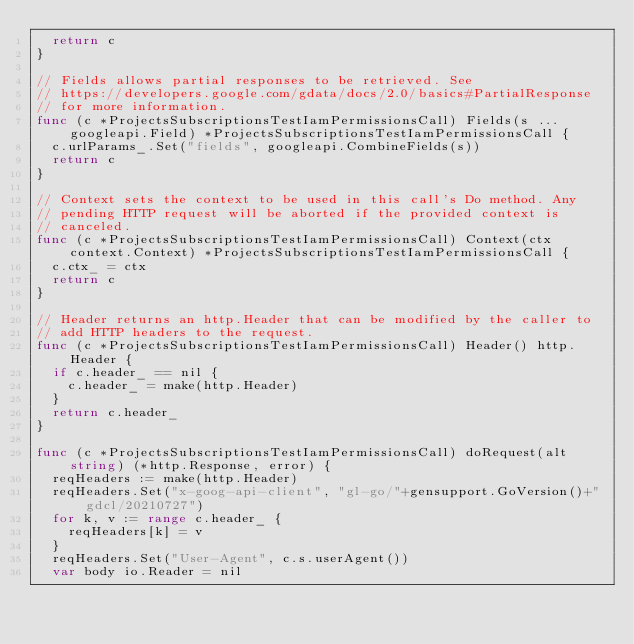<code> <loc_0><loc_0><loc_500><loc_500><_Go_>	return c
}

// Fields allows partial responses to be retrieved. See
// https://developers.google.com/gdata/docs/2.0/basics#PartialResponse
// for more information.
func (c *ProjectsSubscriptionsTestIamPermissionsCall) Fields(s ...googleapi.Field) *ProjectsSubscriptionsTestIamPermissionsCall {
	c.urlParams_.Set("fields", googleapi.CombineFields(s))
	return c
}

// Context sets the context to be used in this call's Do method. Any
// pending HTTP request will be aborted if the provided context is
// canceled.
func (c *ProjectsSubscriptionsTestIamPermissionsCall) Context(ctx context.Context) *ProjectsSubscriptionsTestIamPermissionsCall {
	c.ctx_ = ctx
	return c
}

// Header returns an http.Header that can be modified by the caller to
// add HTTP headers to the request.
func (c *ProjectsSubscriptionsTestIamPermissionsCall) Header() http.Header {
	if c.header_ == nil {
		c.header_ = make(http.Header)
	}
	return c.header_
}

func (c *ProjectsSubscriptionsTestIamPermissionsCall) doRequest(alt string) (*http.Response, error) {
	reqHeaders := make(http.Header)
	reqHeaders.Set("x-goog-api-client", "gl-go/"+gensupport.GoVersion()+" gdcl/20210727")
	for k, v := range c.header_ {
		reqHeaders[k] = v
	}
	reqHeaders.Set("User-Agent", c.s.userAgent())
	var body io.Reader = nil</code> 